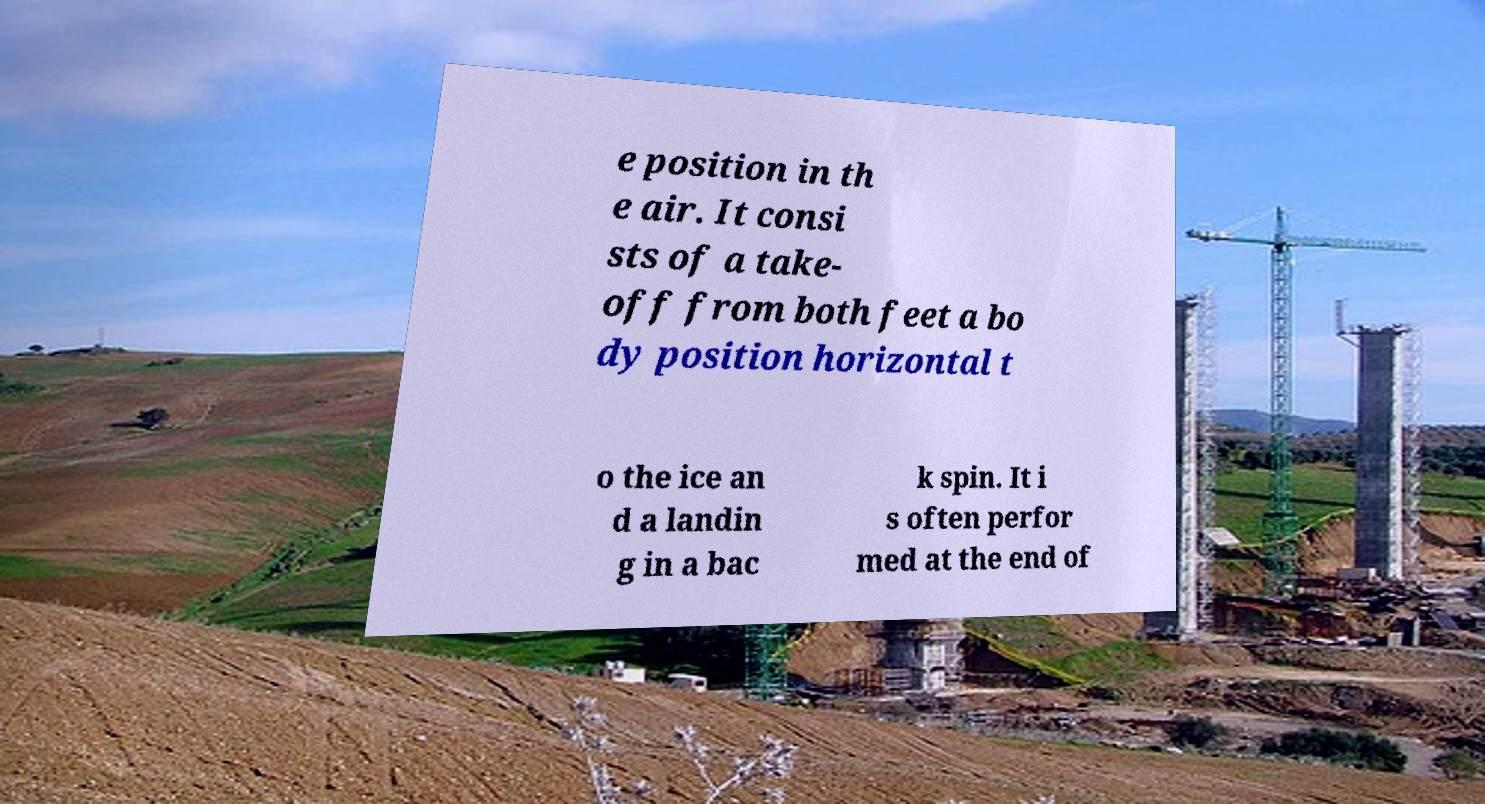For documentation purposes, I need the text within this image transcribed. Could you provide that? e position in th e air. It consi sts of a take- off from both feet a bo dy position horizontal t o the ice an d a landin g in a bac k spin. It i s often perfor med at the end of 